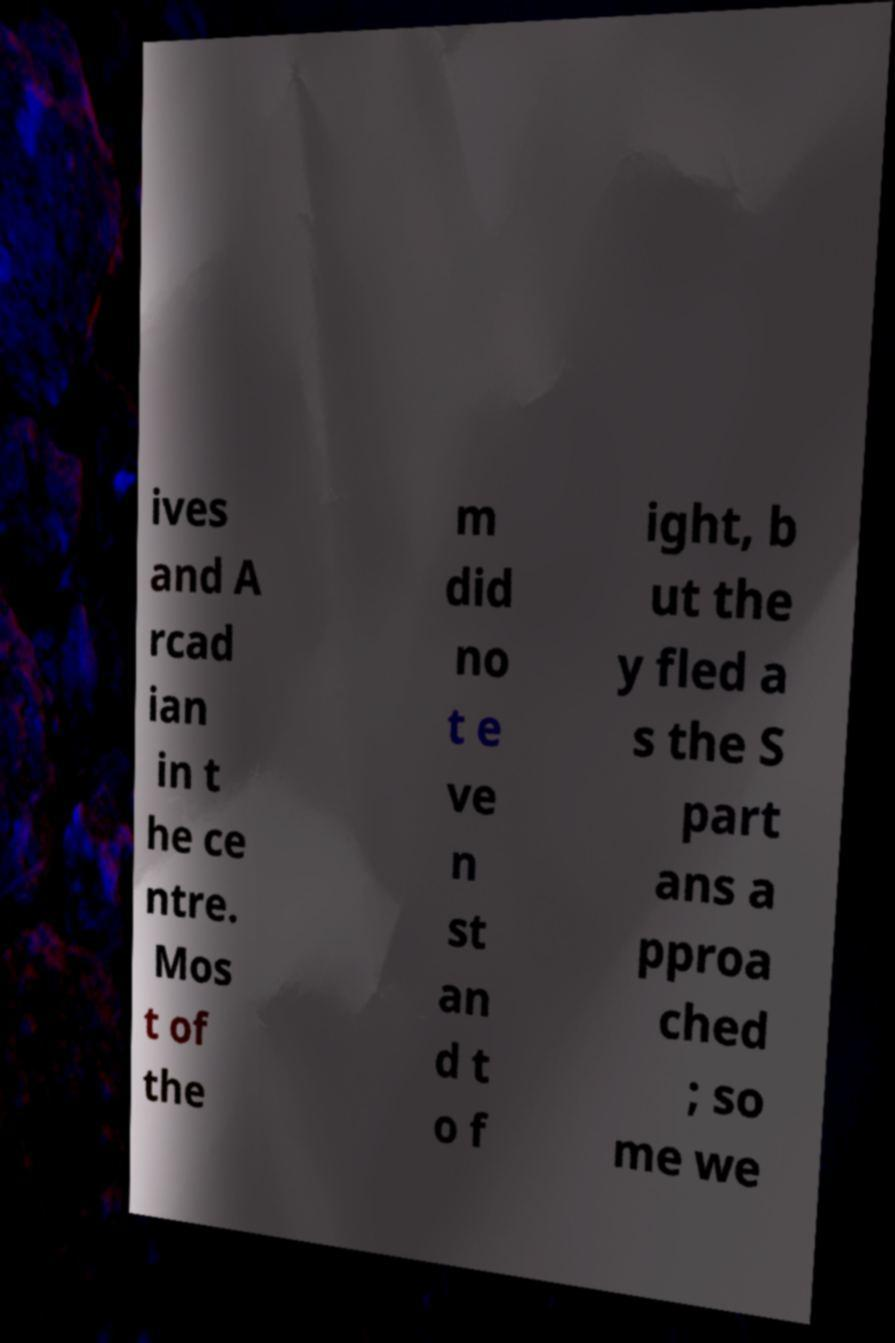There's text embedded in this image that I need extracted. Can you transcribe it verbatim? ives and A rcad ian in t he ce ntre. Mos t of the m did no t e ve n st an d t o f ight, b ut the y fled a s the S part ans a pproa ched ; so me we 